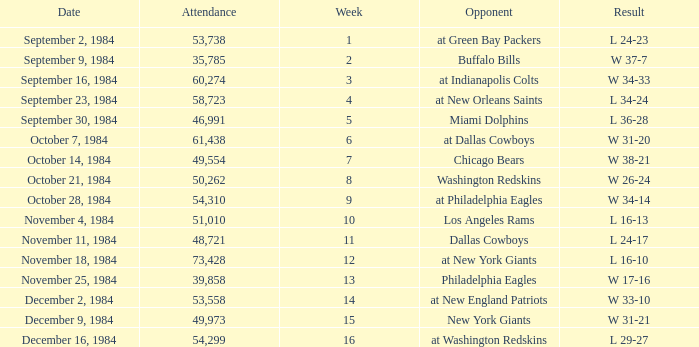Who was the opponent on October 14, 1984? Chicago Bears. 